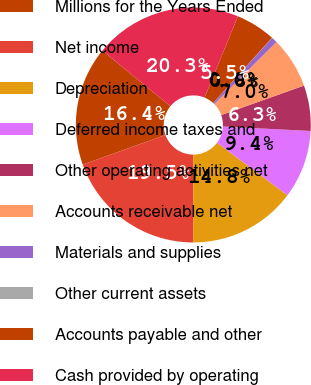Convert chart to OTSL. <chart><loc_0><loc_0><loc_500><loc_500><pie_chart><fcel>Millions for the Years Ended<fcel>Net income<fcel>Depreciation<fcel>Deferred income taxes and<fcel>Other operating activities net<fcel>Accounts receivable net<fcel>Materials and supplies<fcel>Other current assets<fcel>Accounts payable and other<fcel>Cash provided by operating<nl><fcel>16.39%<fcel>19.5%<fcel>14.83%<fcel>9.38%<fcel>6.26%<fcel>7.04%<fcel>0.81%<fcel>0.03%<fcel>5.48%<fcel>20.28%<nl></chart> 